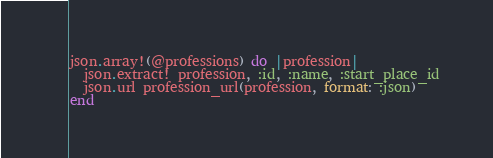Convert code to text. <code><loc_0><loc_0><loc_500><loc_500><_Ruby_>json.array!(@professions) do |profession|
  json.extract! profession, :id, :name, :start_place_id
  json.url profession_url(profession, format: :json)
end
</code> 